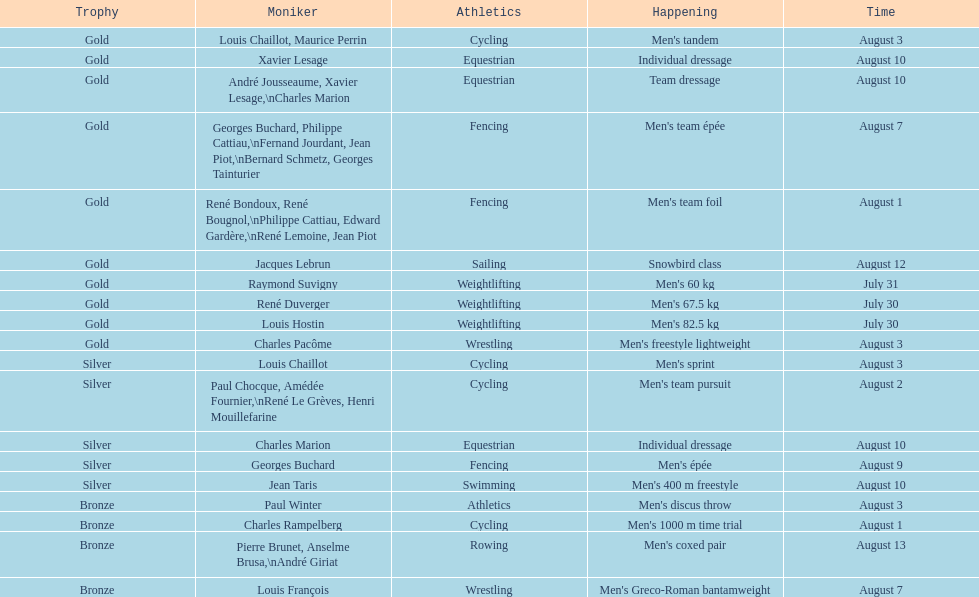How many medals were won after august 3? 9. 